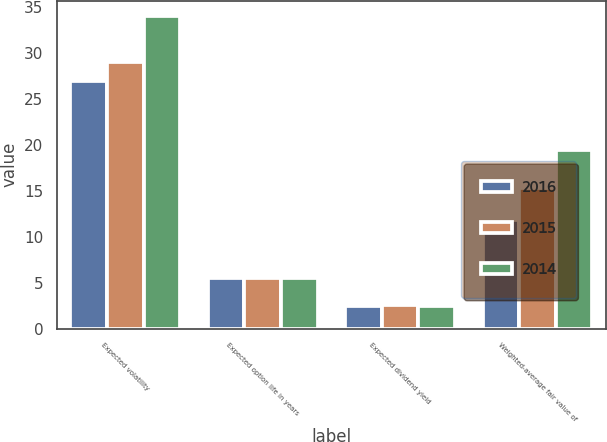Convert chart to OTSL. <chart><loc_0><loc_0><loc_500><loc_500><stacked_bar_chart><ecel><fcel>Expected volatility<fcel>Expected option life in years<fcel>Expected dividend yield<fcel>Weighted-average fair value of<nl><fcel>2016<fcel>27<fcel>5.5<fcel>2.5<fcel>11.8<nl><fcel>2015<fcel>29<fcel>5.5<fcel>2.6<fcel>15.25<nl><fcel>2014<fcel>34<fcel>5.5<fcel>2.4<fcel>19.46<nl></chart> 